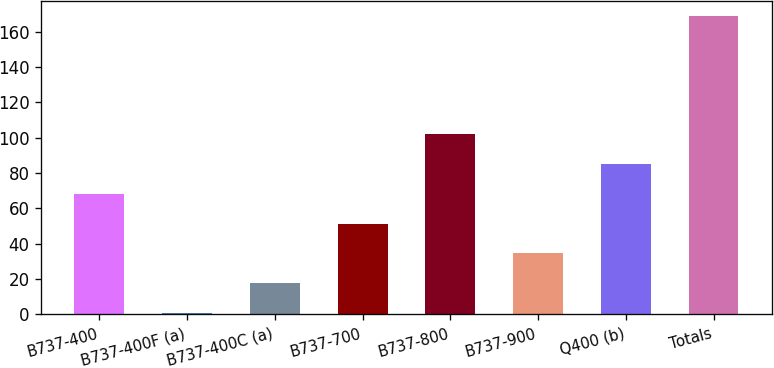<chart> <loc_0><loc_0><loc_500><loc_500><bar_chart><fcel>B737-400<fcel>B737-400F (a)<fcel>B737-400C (a)<fcel>B737-700<fcel>B737-800<fcel>B737-900<fcel>Q400 (b)<fcel>Totals<nl><fcel>68.2<fcel>1<fcel>17.8<fcel>51.4<fcel>101.8<fcel>34.6<fcel>85<fcel>169<nl></chart> 